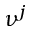<formula> <loc_0><loc_0><loc_500><loc_500>\nu ^ { j }</formula> 